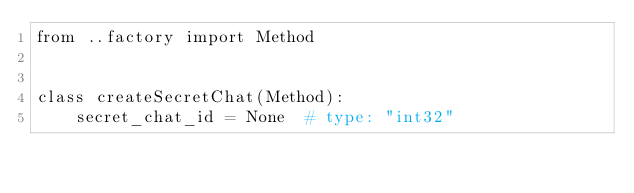<code> <loc_0><loc_0><loc_500><loc_500><_Python_>from ..factory import Method


class createSecretChat(Method):
	secret_chat_id = None  # type: "int32"
</code> 